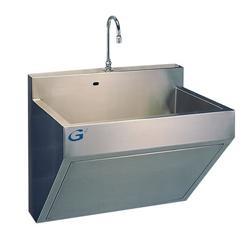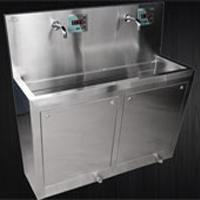The first image is the image on the left, the second image is the image on the right. Evaluate the accuracy of this statement regarding the images: "Each image shows a steel sink with an undivided rectangular basin, but the sink on the right has a longer 'bin' under it.". Is it true? Answer yes or no. Yes. 